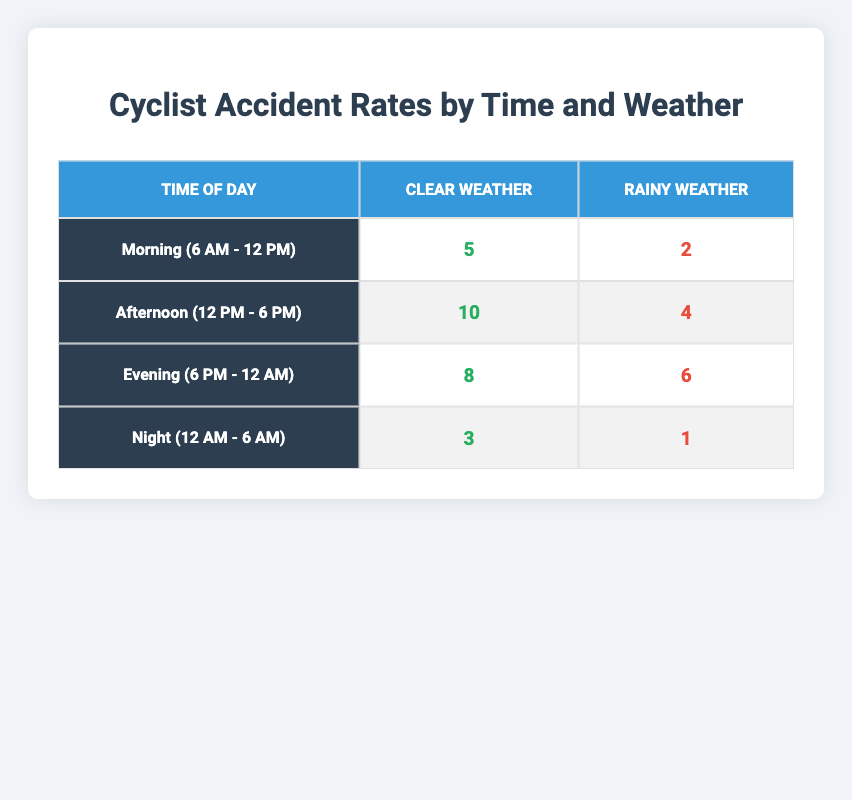What time of day had the highest number of accidents in clear weather? In the table, we look for the highest "AccidentCount" value under "Clear Weather." The highest count is found in the "Afternoon (12 PM - 6 PM)" row with 10 accidents.
Answer: Afternoon (12 PM - 6 PM) How many accidents occurred during the evening when the weather was rainy? We can find the "AccidentCount" for "Evening (6 PM - 12 AM)" under "Rainy Weather" in the table. It shows a count of 6 accidents.
Answer: 6 What is the total number of accidents reported during rainy weather? To find the total for rainy weather, we sum the "AccidentCount" values from all "Rainy" rows: 2 (Morning) + 4 (Afternoon) + 6 (Evening) + 1 (Night) = 13.
Answer: 13 Is it true that the number of accidents in the morning is less than in the evening for rainy weather? In the table, for "Rainy Weather," the morning had 2 accidents and the evening had 6 accidents. Since 2 is less than 6, the statement is true.
Answer: Yes What is the average number of accidents for each time of day? We calculate the average by first summing the accidents for each time period. For Morning: 5 + 2 = 7, Afternoon: 10 + 4 = 14, Evening: 8 + 6 = 14, Night: 3 + 1 = 4. The averages are 7/2 = 3.5, 14/2 = 7, 14/2 = 7, 4/2 = 2. Average values for each time are therefore: Morning 3.5, Afternoon 7, Evening 7, Night 2.
Answer: Morning 3.5, Afternoon 7, Evening 7, Night 2 